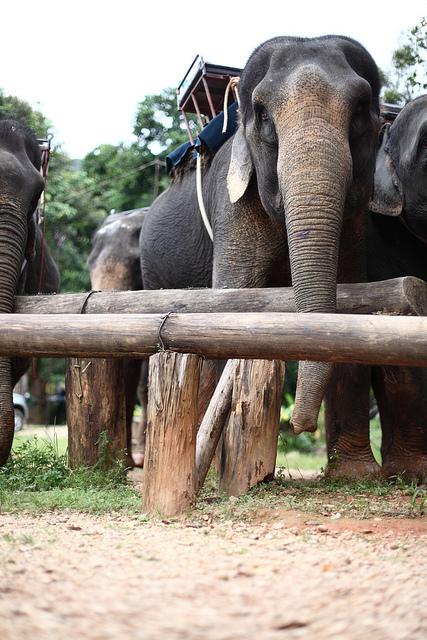What the elephants wearing on their back?
Be succinct. Seats. Do these elephants have tusk?
Quick response, please. No. Are these wild elephants?
Write a very short answer. No. 